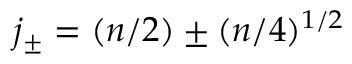<formula> <loc_0><loc_0><loc_500><loc_500>j _ { \pm } = ( n / 2 ) \pm ( n / 4 ) ^ { 1 / 2 }</formula> 